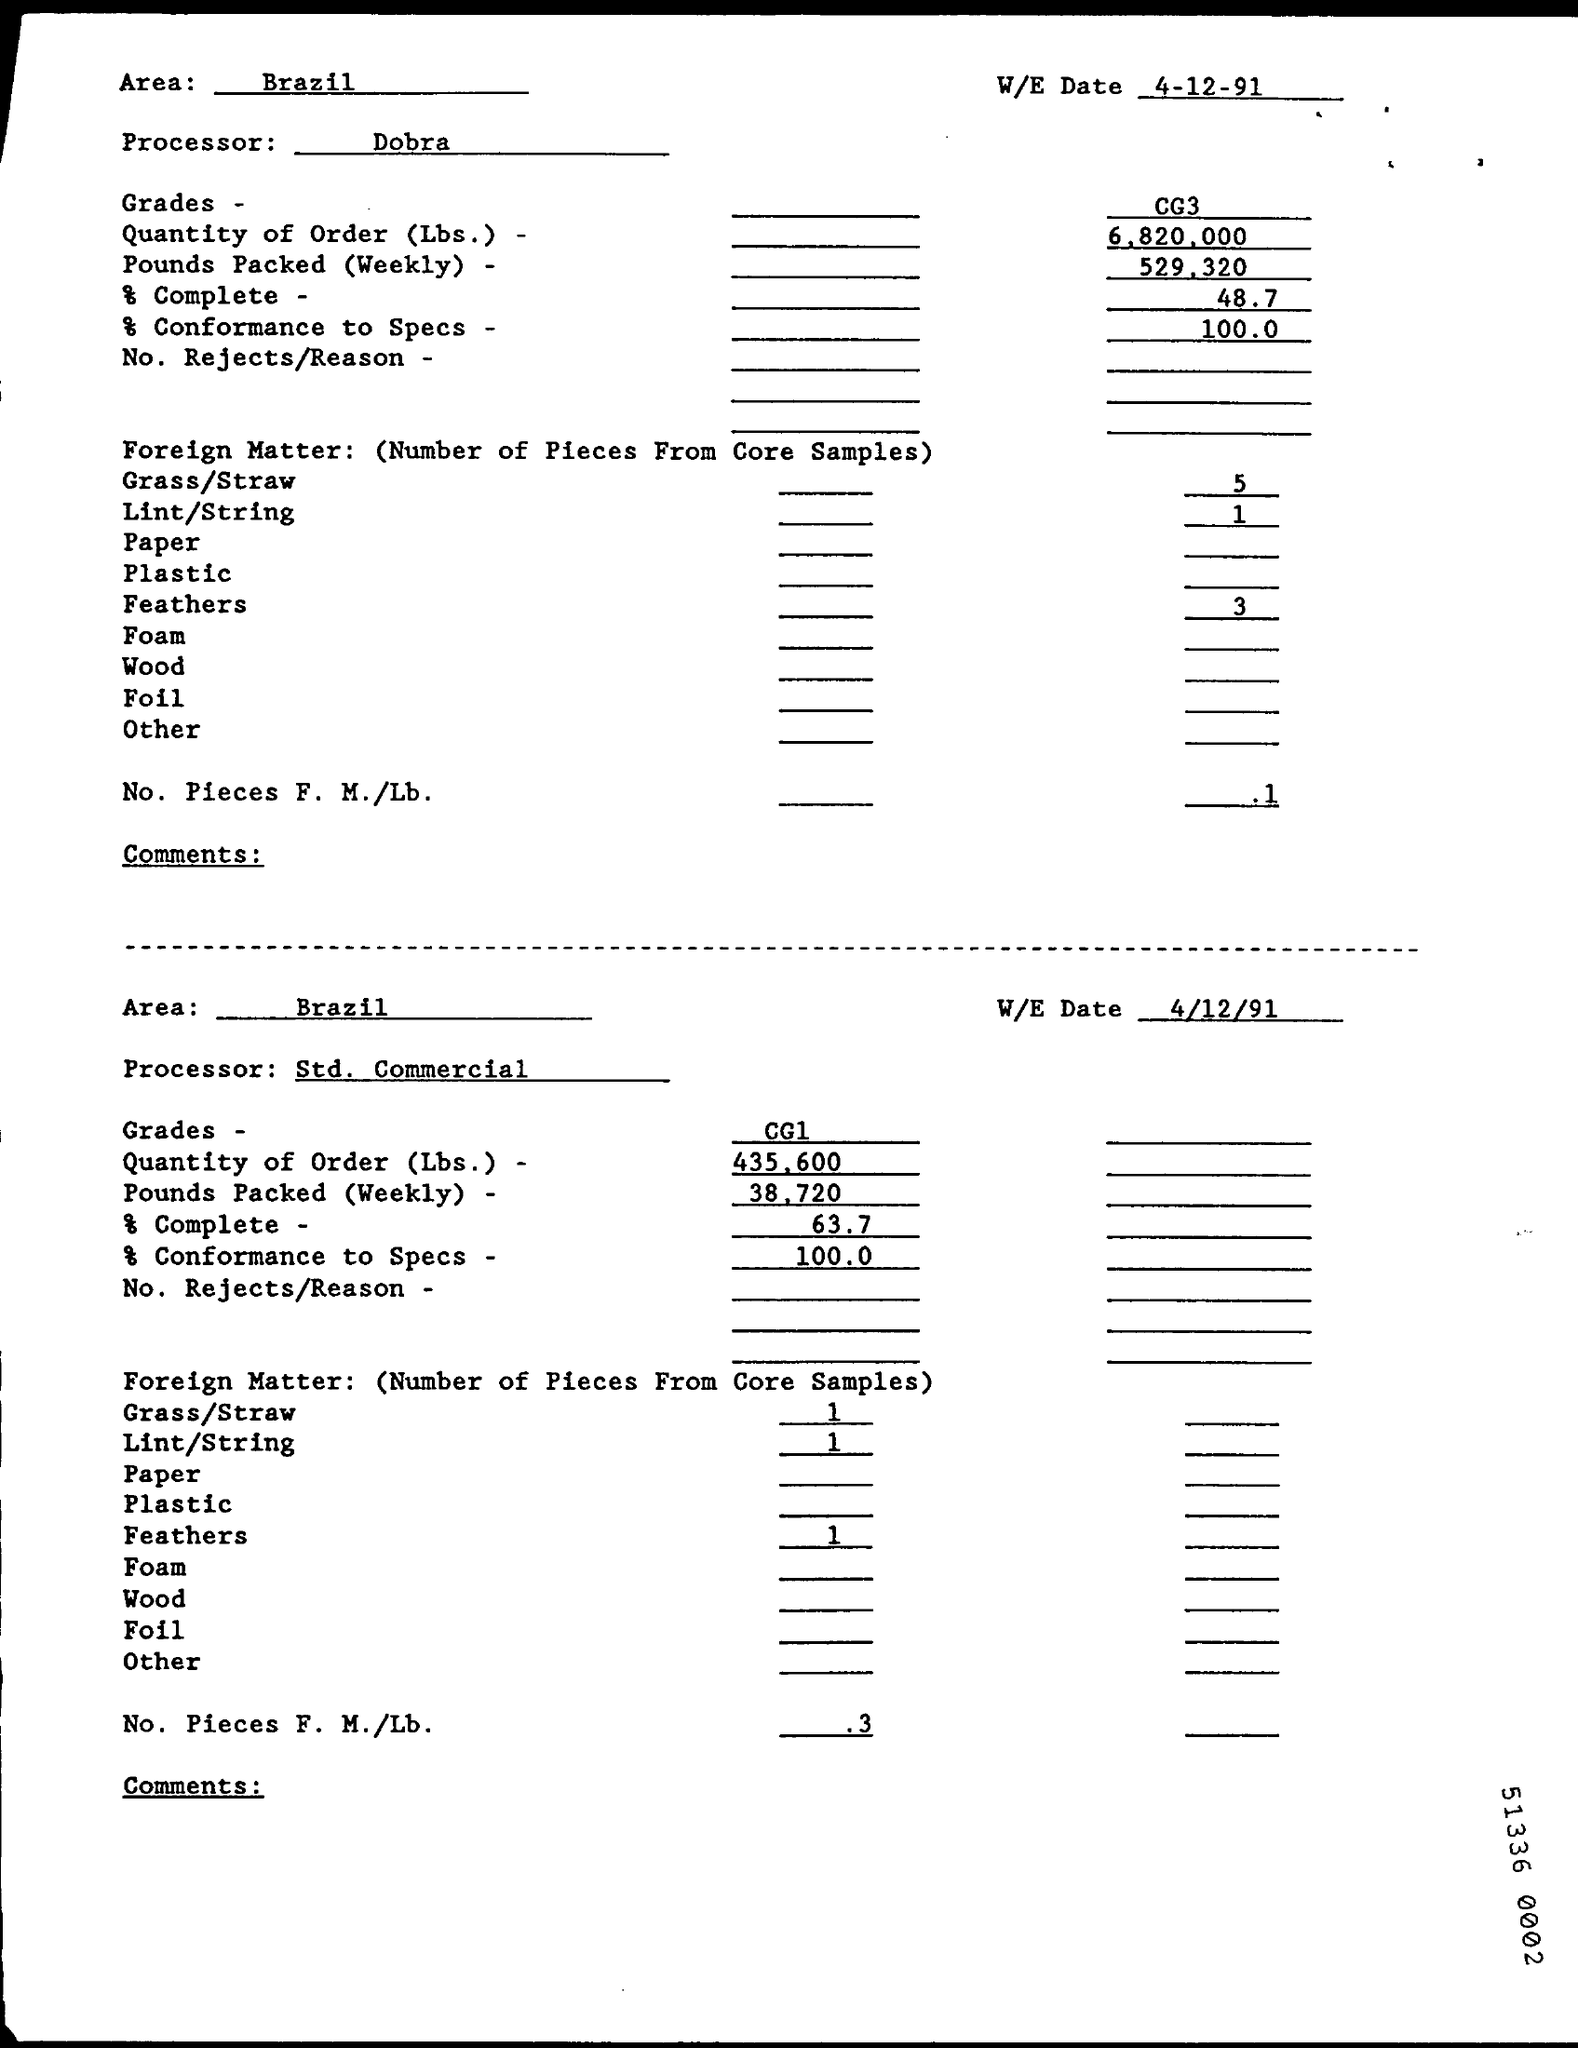Indicate a few pertinent items in this graphic. The area of Brazil is mentioned. A total of five pieces of grass and straw were discovered in the core samples. The processor in the first part of the form is Dobra. 